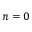Convert formula to latex. <formula><loc_0><loc_0><loc_500><loc_500>n = 0</formula> 